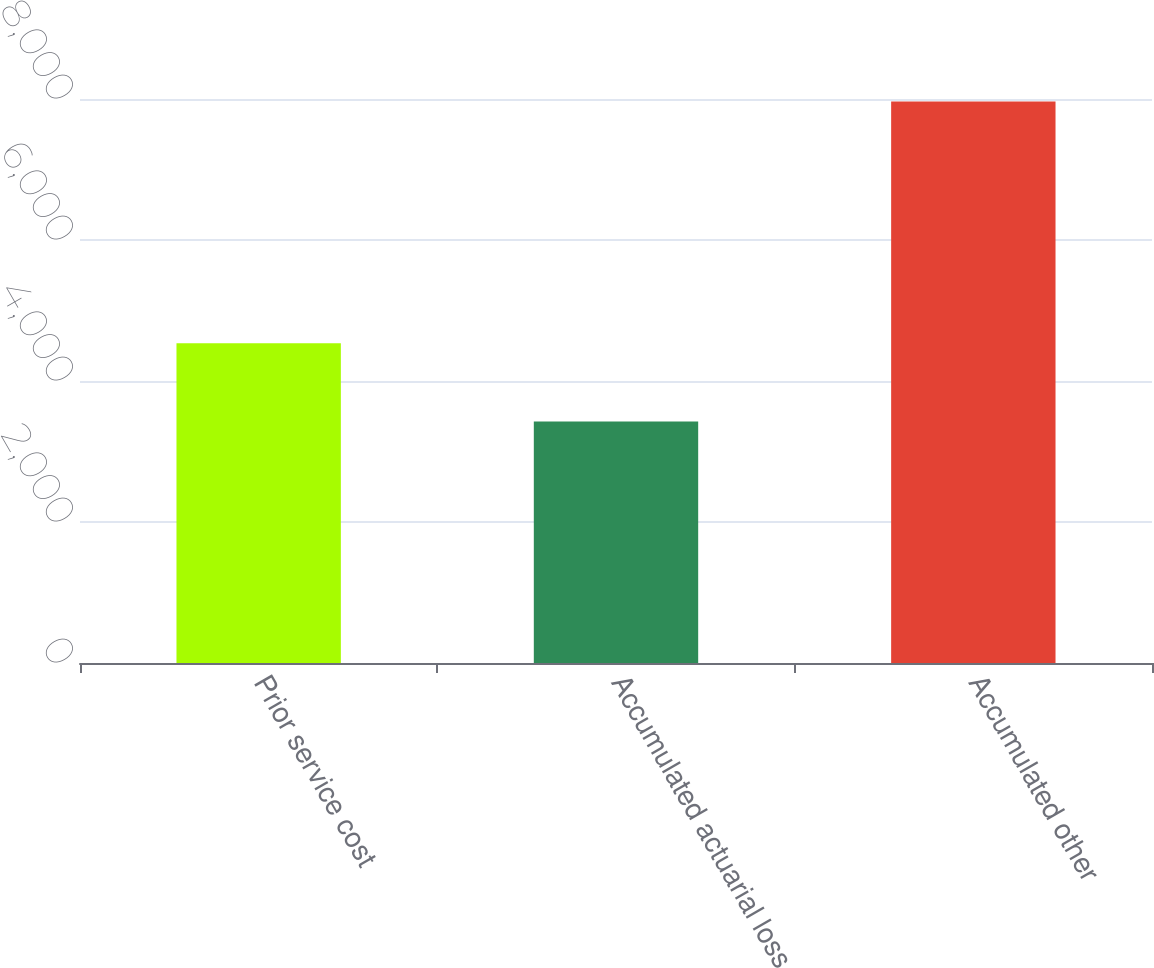Convert chart. <chart><loc_0><loc_0><loc_500><loc_500><bar_chart><fcel>Prior service cost<fcel>Accumulated actuarial loss<fcel>Accumulated other<nl><fcel>4537<fcel>3426<fcel>7963<nl></chart> 